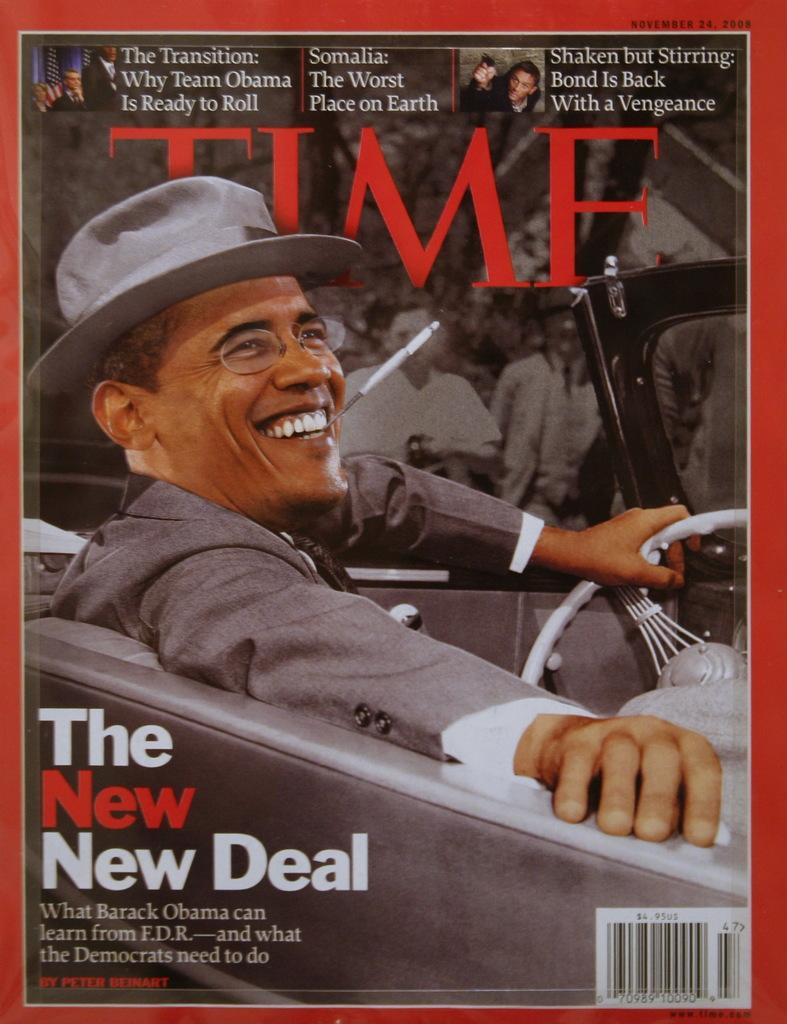<image>
Write a terse but informative summary of the picture. Time magazine with Barack Obama on the cover. 